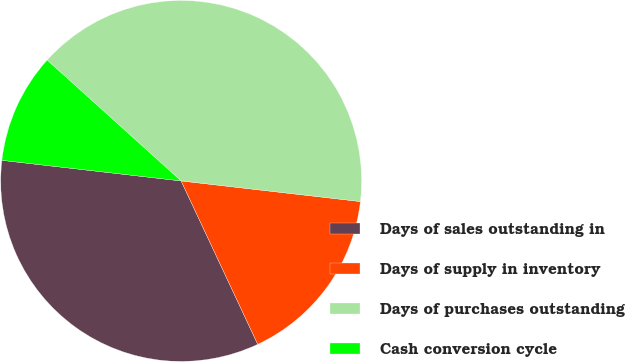<chart> <loc_0><loc_0><loc_500><loc_500><pie_chart><fcel>Days of sales outstanding in<fcel>Days of supply in inventory<fcel>Days of purchases outstanding<fcel>Cash conversion cycle<nl><fcel>33.8%<fcel>16.2%<fcel>40.14%<fcel>9.86%<nl></chart> 